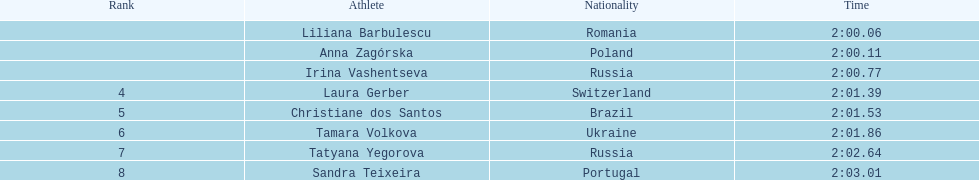Who were the competitors? Liliana Barbulescu, 2:00.06, Anna Zagórska, 2:00.11, Irina Vashentseva, 2:00.77, Laura Gerber, 2:01.39, Christiane dos Santos, 2:01.53, Tamara Volkova, 2:01.86, Tatyana Yegorova, 2:02.64, Sandra Teixeira, 2:03.01. Who got the second position? Anna Zagórska, 2:00.11. What was her timing? 2:00.11. 